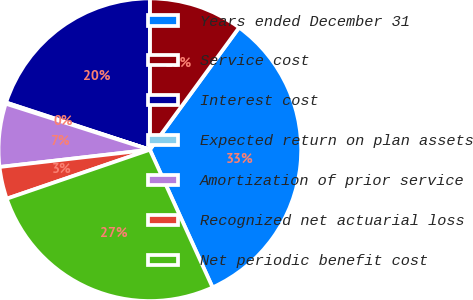<chart> <loc_0><loc_0><loc_500><loc_500><pie_chart><fcel>Years ended December 31<fcel>Service cost<fcel>Interest cost<fcel>Expected return on plan assets<fcel>Amortization of prior service<fcel>Recognized net actuarial loss<fcel>Net periodic benefit cost<nl><fcel>33.16%<fcel>10.04%<fcel>19.95%<fcel>0.13%<fcel>6.74%<fcel>3.43%<fcel>26.55%<nl></chart> 